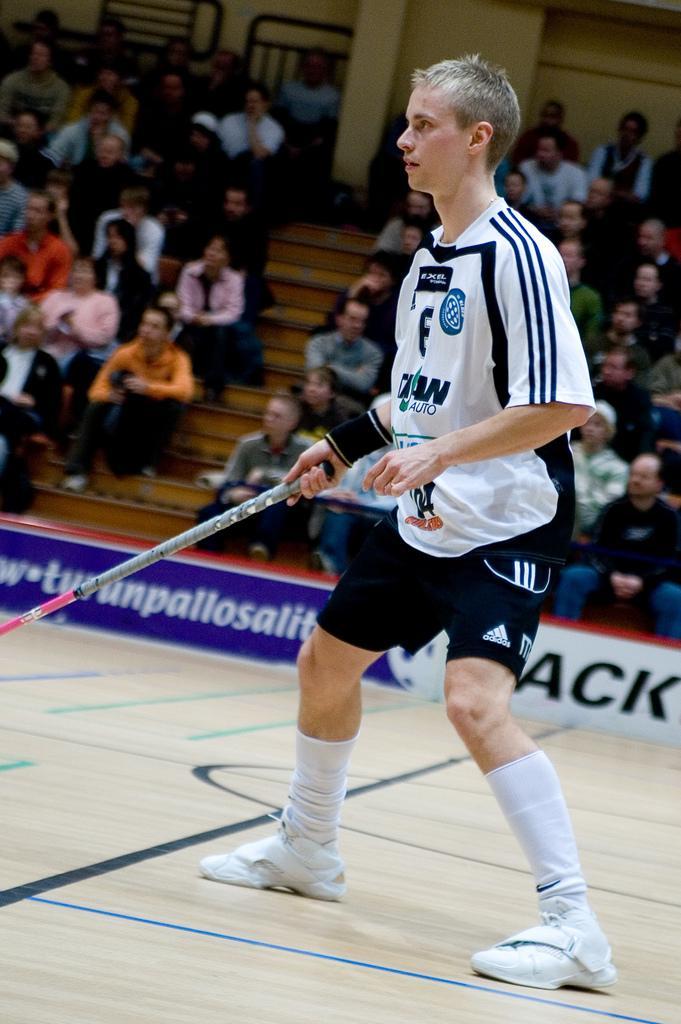Could you give a brief overview of what you see in this image? This picture describes about group of people, few are seated, in front of them we can see a hoarding, in the middle of the image we can find a man, he is holding a stick. 